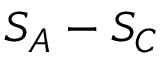Convert formula to latex. <formula><loc_0><loc_0><loc_500><loc_500>S _ { A } - S _ { C }</formula> 